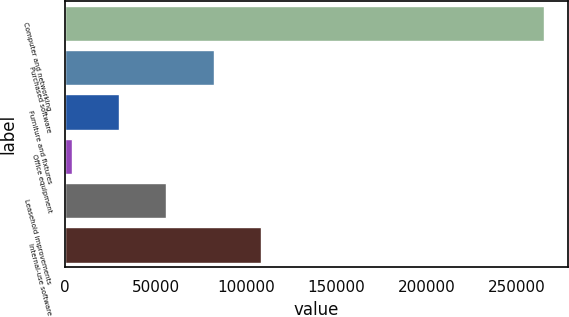Convert chart. <chart><loc_0><loc_0><loc_500><loc_500><bar_chart><fcel>Computer and networking<fcel>Purchased software<fcel>Furniture and fixtures<fcel>Office equipment<fcel>Leasehold improvements<fcel>Internal-use software<nl><fcel>264949<fcel>82193.7<fcel>29977.9<fcel>3870<fcel>56085.8<fcel>108302<nl></chart> 